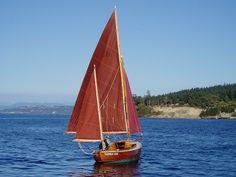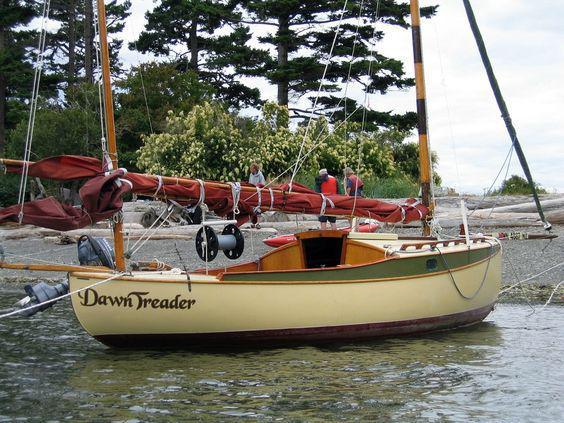The first image is the image on the left, the second image is the image on the right. Given the left and right images, does the statement "In at least one image shows a boat with a visible name on its hull." hold true? Answer yes or no. Yes. 